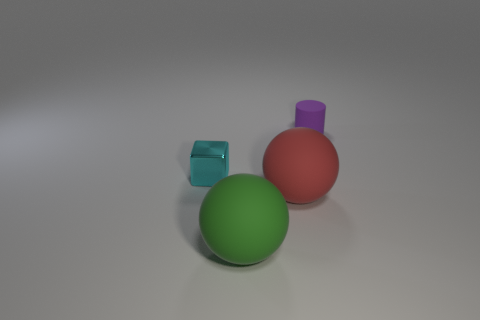Is there anything else that has the same material as the cyan block?
Make the answer very short. No. What is the color of the tiny cylinder?
Make the answer very short. Purple. What is the material of the thing that is behind the large red matte thing and left of the purple rubber cylinder?
Your response must be concise. Metal. Is there a purple cylinder that is on the right side of the tiny object to the left of the tiny object to the right of the tiny block?
Provide a succinct answer. Yes. Are there any red matte things to the right of the cyan shiny block?
Provide a succinct answer. Yes. What number of other objects are the same shape as the metallic object?
Provide a short and direct response. 0. What color is the other thing that is the same size as the purple thing?
Give a very brief answer. Cyan. Are there fewer matte cylinders that are in front of the small cylinder than big rubber spheres behind the green sphere?
Offer a terse response. Yes. There is a rubber thing behind the large object behind the green ball; how many red matte spheres are to the left of it?
Offer a terse response. 1. Is the number of small cyan metallic blocks that are behind the cyan object less than the number of tiny red shiny blocks?
Offer a terse response. No. 